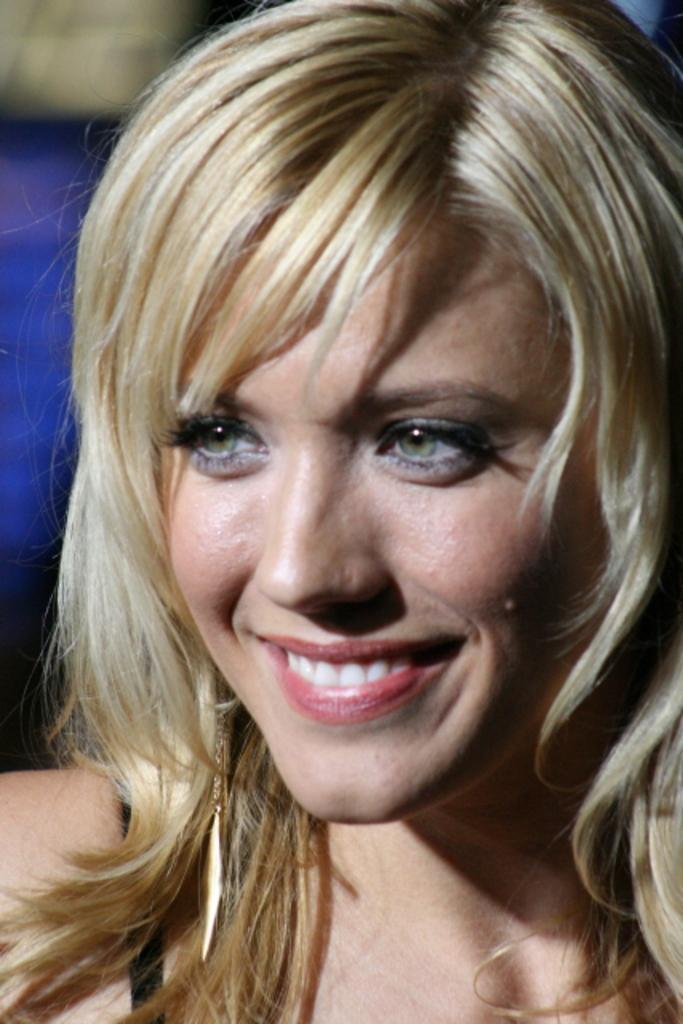Can you describe this image briefly? In this image the background is a little blurred. In the middle of the image there is a woman and she is with a smiling face. 